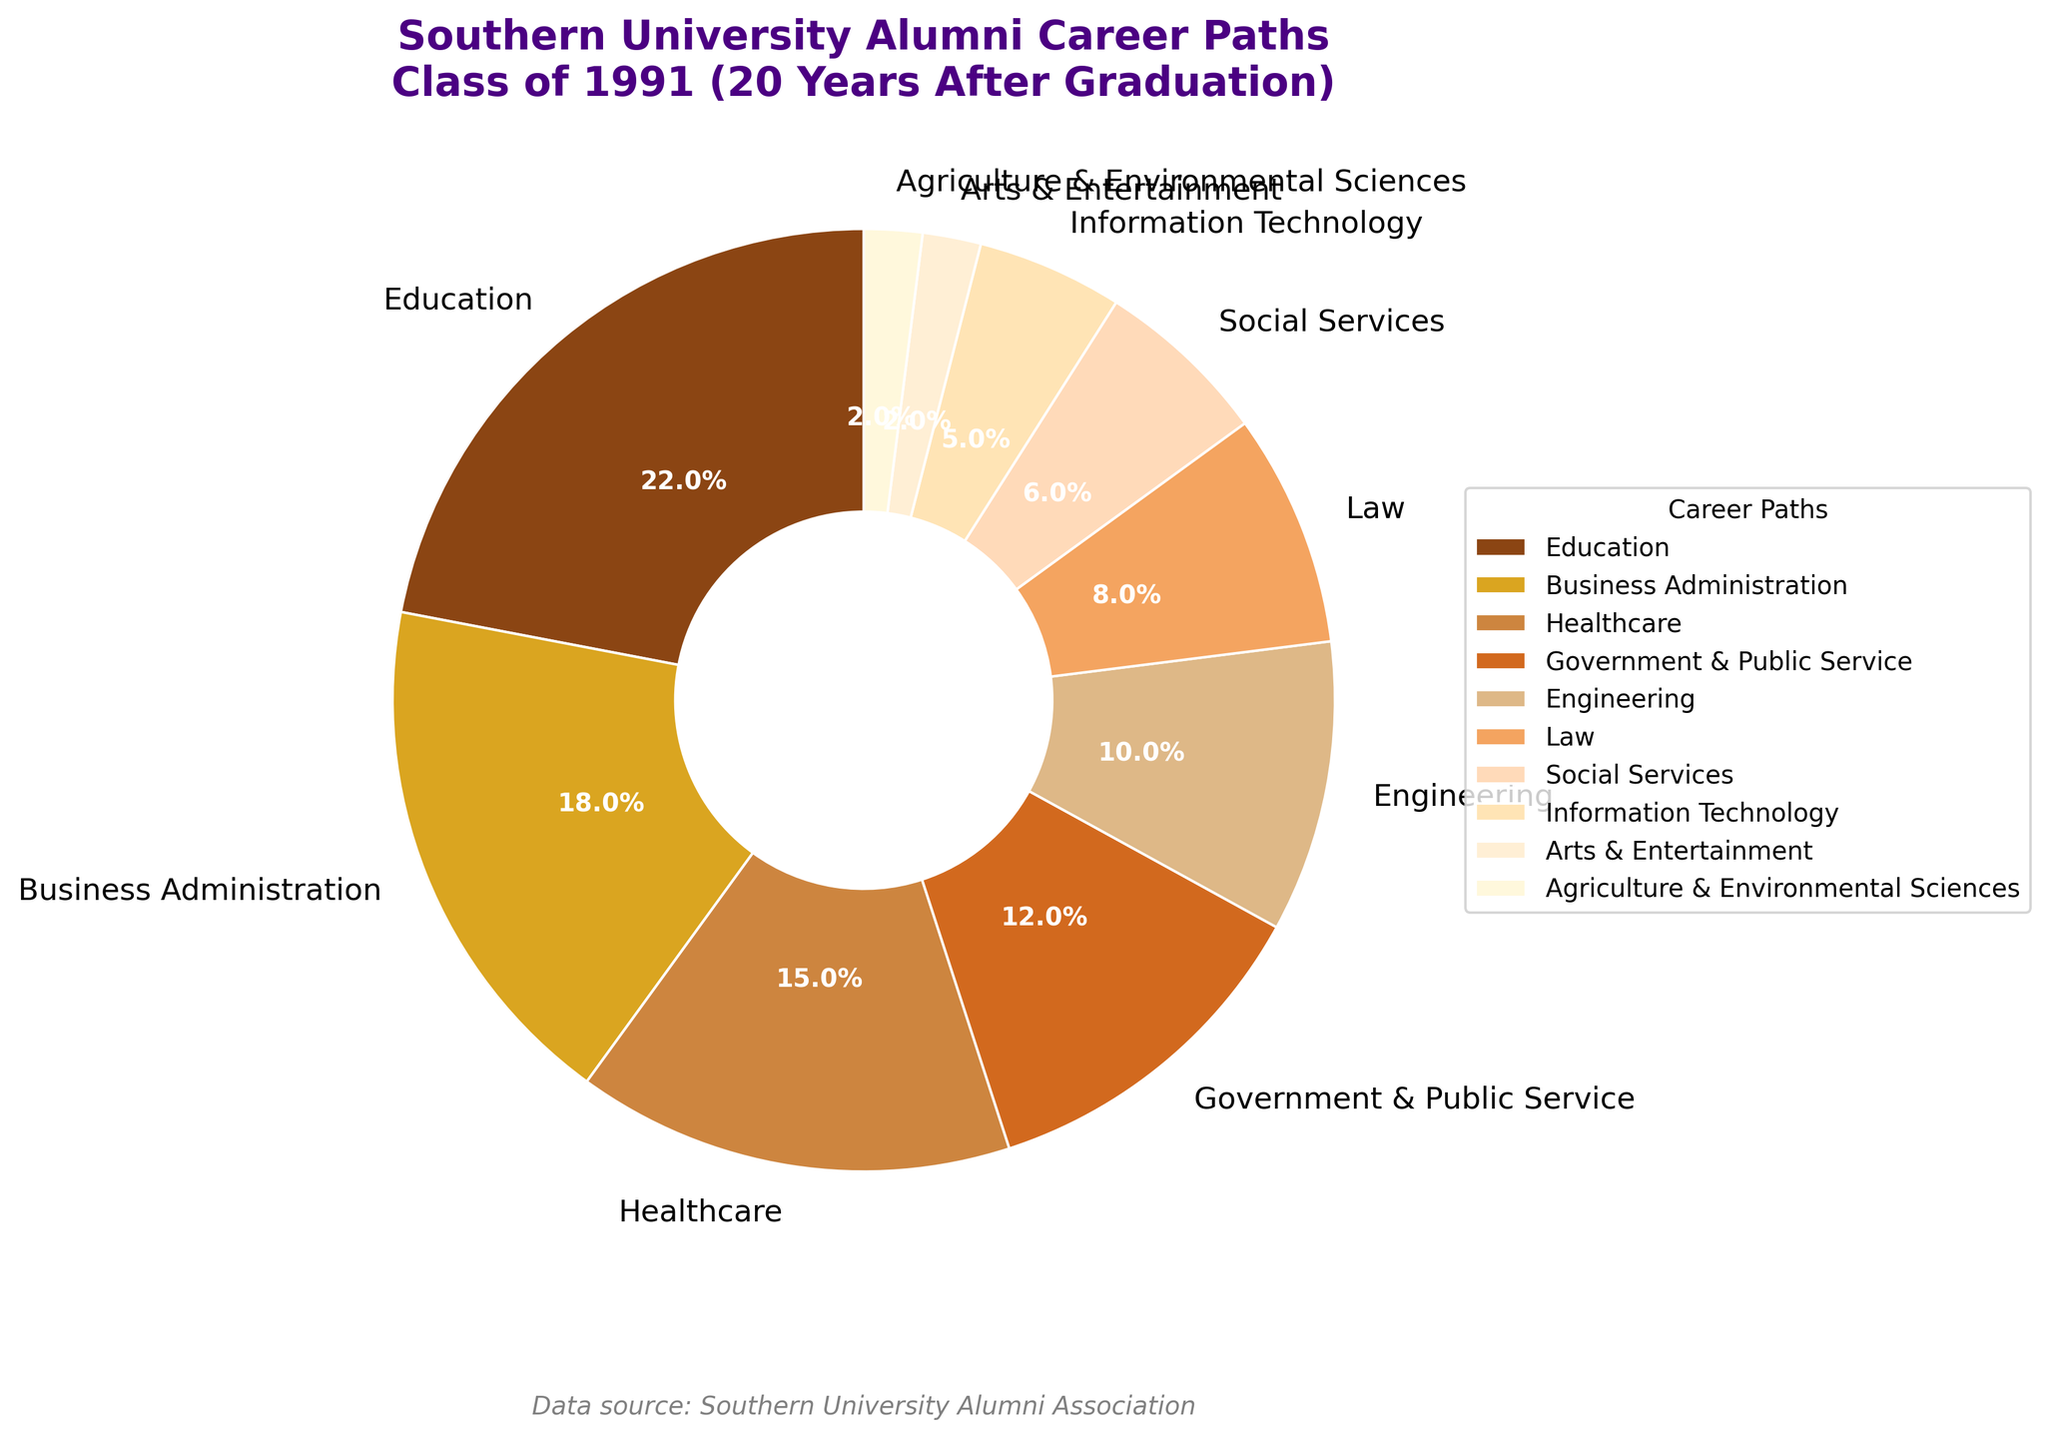What is the most prevalent career path for the Southern University class of 1991 alumni 20 years after graduation? The pie chart shows the alumni career paths with the highest percentage. The largest wedge corresponds to Education, with 22%.
Answer: Education Which career paths combined make up over 50% of the alumni's career distribution? Sum the percentages of the largest categories until the total exceeds 50%. Education (22%) + Business Administration (18%) + Healthcare (15%) equals 55%. Thus, these three career paths together make up over 50%.
Answer: Education, Business Administration, Healthcare How much larger is the percentage of alumni in Education compared to those in Information Technology? Subtract the percentage of alumni in Information Technology from the percentage in Education: 22% - 5% = 17%.
Answer: 17% Which career path has the smallest representation among the alumni? The pie chart shows the smallest wedge, which corresponds to both Arts & Entertainment and Agriculture & Environmental Sciences, each with 2%.
Answer: Arts & Entertainment and Agriculture & Environmental Sciences How do the percentages of alumni in Law and Engineering compare? Compare the values directly from the pie chart: Law is 8% and Engineering is 10%. Therefore, Engineering has a higher percentage.
Answer: Engineering What is the total percentage of alumni working in fields related to serving the public, including Education and Government & Public Service? Sum the percentages of alumni in Education (22%) and Government & Public Service (12%): 22% + 12% = 34%.
Answer: 34% If you combine the percentages of alumni working in Social Services and Healthcare, does the total exceed the percentage of those in Business Administration? Sum the percentages of Social Services (6%) and Healthcare (15%): 6% + 15% = 21%. Compare this to Business Administration, which is 18%. Yes, the total exceeds the percentage in Business Administration.
Answer: Yes What are the distinct colors used in the chart to represent the categories, starting from the largest segment? Identify the colors corresponding to the categories from the Education segment to the smallest segments: shades of brown and gold.
Answer: Shades of brown and gold Which professions have a combined percentage of less than 10%? Sum combinations of the smallest percentages and see if they are less than 10%. Arts & Entertainment (2%) + Agriculture & Environmental Sciences (2%) + Information Technology (5%) totals 9%. Thus, they are below 10%.
Answer: Arts & Entertainment, Agriculture & Environmental Sciences, Information Technology Which career paths have similar or equal representations? Look for wedges in the pie chart that have equal or very close percentages. The career paths with similar percentages are Arts & Entertainment (2%) and Agriculture & Environmental Sciences (2%), both are equal.
Answer: Arts & Entertainment and Agriculture & Environmental Sciences 